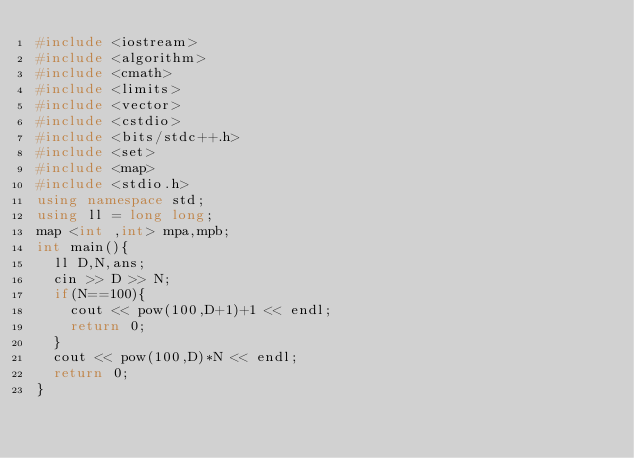Convert code to text. <code><loc_0><loc_0><loc_500><loc_500><_C++_>#include <iostream>
#include <algorithm>
#include <cmath>
#include <limits>
#include <vector>
#include <cstdio>
#include <bits/stdc++.h>
#include <set>
#include <map>
#include <stdio.h>
using namespace std;
using ll = long long;
map <int ,int> mpa,mpb;
int main(){
  ll D,N,ans;
  cin >> D >> N;
  if(N==100){
    cout << pow(100,D+1)+1 << endl;
    return 0;
  }
  cout << pow(100,D)*N << endl;
  return 0;
}</code> 